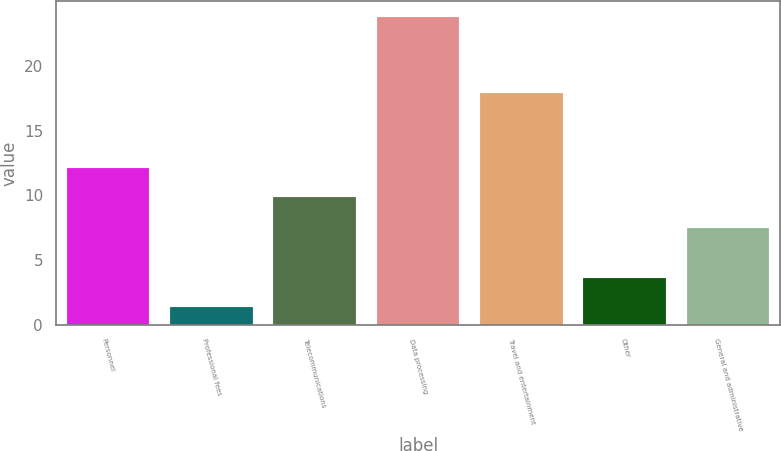Convert chart to OTSL. <chart><loc_0><loc_0><loc_500><loc_500><bar_chart><fcel>Personnel<fcel>Professional fees<fcel>Telecommunications<fcel>Data processing<fcel>Travel and entertainment<fcel>Other<fcel>General and administrative<nl><fcel>12.14<fcel>1.4<fcel>9.9<fcel>23.8<fcel>17.9<fcel>3.64<fcel>7.5<nl></chart> 